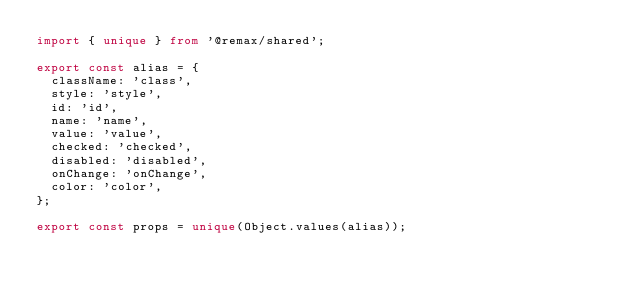Convert code to text. <code><loc_0><loc_0><loc_500><loc_500><_TypeScript_>import { unique } from '@remax/shared';

export const alias = {
  className: 'class',
  style: 'style',
  id: 'id',
  name: 'name',
  value: 'value',
  checked: 'checked',
  disabled: 'disabled',
  onChange: 'onChange',
  color: 'color',
};

export const props = unique(Object.values(alias));
</code> 